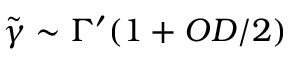<formula> <loc_0><loc_0><loc_500><loc_500>\tilde { \gamma } \sim \Gamma ^ { \prime } ( 1 + O D / 2 )</formula> 